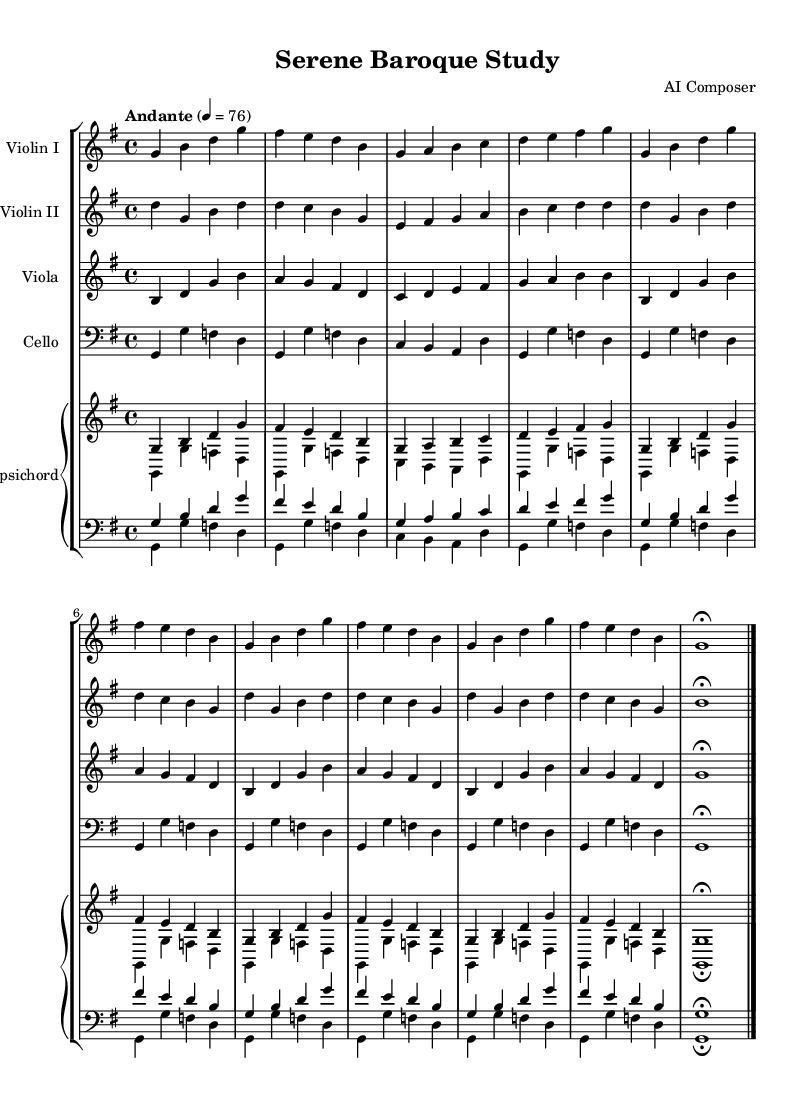What is the key signature of this music? The key signature is G major, which has one sharp (F#).
Answer: G major What is the time signature of this piece? The time signature indicated is 4/4, which means there are four beats in each measure.
Answer: 4/4 What is the tempo marking for this piece? The tempo marking is "Andante," which implies a moderate walking pace.
Answer: Andante How many measures are in the violin I part? By counting the measures indicated in the violin I line, there are a total of 12 measures before the ending.
Answer: 12 measures Which instrument has the lowest pitch in this arrangement? The cello is typically tuned lower than the other strings, making it the lowest-pitched instrument in this orchestration.
Answer: Cello What does the "fermata" indicate for the violin II part? The fermata on the last note indicates to hold it longer than its typical value, allowing for expressive interpretation.
Answer: Hold the note longer Which instruments are included in this orchestration? The orchestration includes two violins, a viola, a cello, and a harpsichord, totaling five distinct parts.
Answer: Five instruments 